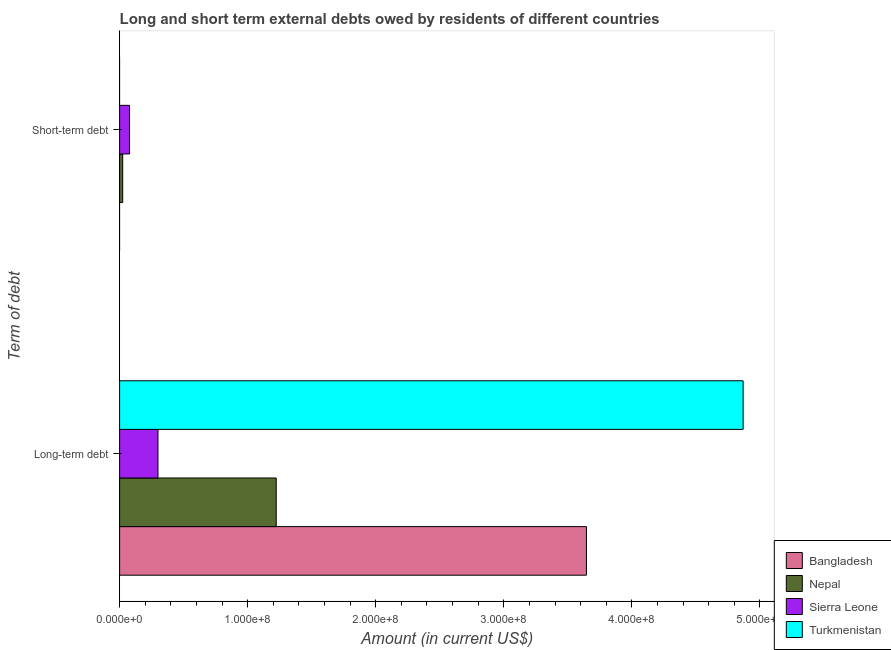How many groups of bars are there?
Provide a succinct answer. 2. Are the number of bars on each tick of the Y-axis equal?
Make the answer very short. No. How many bars are there on the 1st tick from the bottom?
Provide a succinct answer. 4. What is the label of the 1st group of bars from the top?
Your answer should be very brief. Short-term debt. What is the long-term debts owed by residents in Bangladesh?
Provide a succinct answer. 3.65e+08. Across all countries, what is the maximum short-term debts owed by residents?
Keep it short and to the point. 7.77e+06. Across all countries, what is the minimum long-term debts owed by residents?
Provide a short and direct response. 3.00e+07. In which country was the long-term debts owed by residents maximum?
Offer a terse response. Turkmenistan. What is the total short-term debts owed by residents in the graph?
Your answer should be compact. 1.02e+07. What is the difference between the long-term debts owed by residents in Turkmenistan and that in Bangladesh?
Your answer should be compact. 1.22e+08. What is the difference between the short-term debts owed by residents in Turkmenistan and the long-term debts owed by residents in Bangladesh?
Ensure brevity in your answer.  -3.65e+08. What is the average long-term debts owed by residents per country?
Provide a succinct answer. 2.51e+08. What is the difference between the long-term debts owed by residents and short-term debts owed by residents in Sierra Leone?
Keep it short and to the point. 2.22e+07. What is the ratio of the long-term debts owed by residents in Nepal to that in Bangladesh?
Offer a terse response. 0.34. Is the long-term debts owed by residents in Sierra Leone less than that in Bangladesh?
Offer a very short reply. Yes. In how many countries, is the long-term debts owed by residents greater than the average long-term debts owed by residents taken over all countries?
Offer a very short reply. 2. How many bars are there?
Give a very brief answer. 6. Are all the bars in the graph horizontal?
Give a very brief answer. Yes. How many countries are there in the graph?
Your answer should be very brief. 4. Are the values on the major ticks of X-axis written in scientific E-notation?
Keep it short and to the point. Yes. How are the legend labels stacked?
Your response must be concise. Vertical. What is the title of the graph?
Give a very brief answer. Long and short term external debts owed by residents of different countries. What is the label or title of the Y-axis?
Ensure brevity in your answer.  Term of debt. What is the Amount (in current US$) of Bangladesh in Long-term debt?
Your answer should be very brief. 3.65e+08. What is the Amount (in current US$) in Nepal in Long-term debt?
Ensure brevity in your answer.  1.22e+08. What is the Amount (in current US$) of Sierra Leone in Long-term debt?
Offer a terse response. 3.00e+07. What is the Amount (in current US$) in Turkmenistan in Long-term debt?
Your answer should be very brief. 4.87e+08. What is the Amount (in current US$) in Bangladesh in Short-term debt?
Give a very brief answer. 0. What is the Amount (in current US$) in Nepal in Short-term debt?
Offer a very short reply. 2.42e+06. What is the Amount (in current US$) in Sierra Leone in Short-term debt?
Your answer should be very brief. 7.77e+06. What is the Amount (in current US$) in Turkmenistan in Short-term debt?
Offer a very short reply. 0. Across all Term of debt, what is the maximum Amount (in current US$) in Bangladesh?
Your response must be concise. 3.65e+08. Across all Term of debt, what is the maximum Amount (in current US$) of Nepal?
Make the answer very short. 1.22e+08. Across all Term of debt, what is the maximum Amount (in current US$) in Sierra Leone?
Keep it short and to the point. 3.00e+07. Across all Term of debt, what is the maximum Amount (in current US$) of Turkmenistan?
Your response must be concise. 4.87e+08. Across all Term of debt, what is the minimum Amount (in current US$) of Nepal?
Your response must be concise. 2.42e+06. Across all Term of debt, what is the minimum Amount (in current US$) in Sierra Leone?
Provide a short and direct response. 7.77e+06. What is the total Amount (in current US$) of Bangladesh in the graph?
Give a very brief answer. 3.65e+08. What is the total Amount (in current US$) of Nepal in the graph?
Give a very brief answer. 1.25e+08. What is the total Amount (in current US$) of Sierra Leone in the graph?
Provide a short and direct response. 3.77e+07. What is the total Amount (in current US$) of Turkmenistan in the graph?
Ensure brevity in your answer.  4.87e+08. What is the difference between the Amount (in current US$) of Nepal in Long-term debt and that in Short-term debt?
Offer a very short reply. 1.20e+08. What is the difference between the Amount (in current US$) of Sierra Leone in Long-term debt and that in Short-term debt?
Offer a very short reply. 2.22e+07. What is the difference between the Amount (in current US$) in Bangladesh in Long-term debt and the Amount (in current US$) in Nepal in Short-term debt?
Your response must be concise. 3.62e+08. What is the difference between the Amount (in current US$) of Bangladesh in Long-term debt and the Amount (in current US$) of Sierra Leone in Short-term debt?
Your answer should be very brief. 3.57e+08. What is the difference between the Amount (in current US$) in Nepal in Long-term debt and the Amount (in current US$) in Sierra Leone in Short-term debt?
Your answer should be compact. 1.15e+08. What is the average Amount (in current US$) in Bangladesh per Term of debt?
Give a very brief answer. 1.82e+08. What is the average Amount (in current US$) of Nepal per Term of debt?
Provide a succinct answer. 6.24e+07. What is the average Amount (in current US$) of Sierra Leone per Term of debt?
Your answer should be very brief. 1.89e+07. What is the average Amount (in current US$) in Turkmenistan per Term of debt?
Your answer should be very brief. 2.43e+08. What is the difference between the Amount (in current US$) of Bangladesh and Amount (in current US$) of Nepal in Long-term debt?
Provide a succinct answer. 2.42e+08. What is the difference between the Amount (in current US$) in Bangladesh and Amount (in current US$) in Sierra Leone in Long-term debt?
Give a very brief answer. 3.35e+08. What is the difference between the Amount (in current US$) of Bangladesh and Amount (in current US$) of Turkmenistan in Long-term debt?
Keep it short and to the point. -1.22e+08. What is the difference between the Amount (in current US$) in Nepal and Amount (in current US$) in Sierra Leone in Long-term debt?
Your answer should be compact. 9.23e+07. What is the difference between the Amount (in current US$) in Nepal and Amount (in current US$) in Turkmenistan in Long-term debt?
Offer a very short reply. -3.65e+08. What is the difference between the Amount (in current US$) in Sierra Leone and Amount (in current US$) in Turkmenistan in Long-term debt?
Keep it short and to the point. -4.57e+08. What is the difference between the Amount (in current US$) in Nepal and Amount (in current US$) in Sierra Leone in Short-term debt?
Make the answer very short. -5.35e+06. What is the ratio of the Amount (in current US$) of Nepal in Long-term debt to that in Short-term debt?
Your answer should be very brief. 50.53. What is the ratio of the Amount (in current US$) in Sierra Leone in Long-term debt to that in Short-term debt?
Your answer should be compact. 3.86. What is the difference between the highest and the second highest Amount (in current US$) in Nepal?
Make the answer very short. 1.20e+08. What is the difference between the highest and the second highest Amount (in current US$) in Sierra Leone?
Provide a succinct answer. 2.22e+07. What is the difference between the highest and the lowest Amount (in current US$) in Bangladesh?
Provide a short and direct response. 3.65e+08. What is the difference between the highest and the lowest Amount (in current US$) of Nepal?
Ensure brevity in your answer.  1.20e+08. What is the difference between the highest and the lowest Amount (in current US$) of Sierra Leone?
Provide a short and direct response. 2.22e+07. What is the difference between the highest and the lowest Amount (in current US$) in Turkmenistan?
Give a very brief answer. 4.87e+08. 